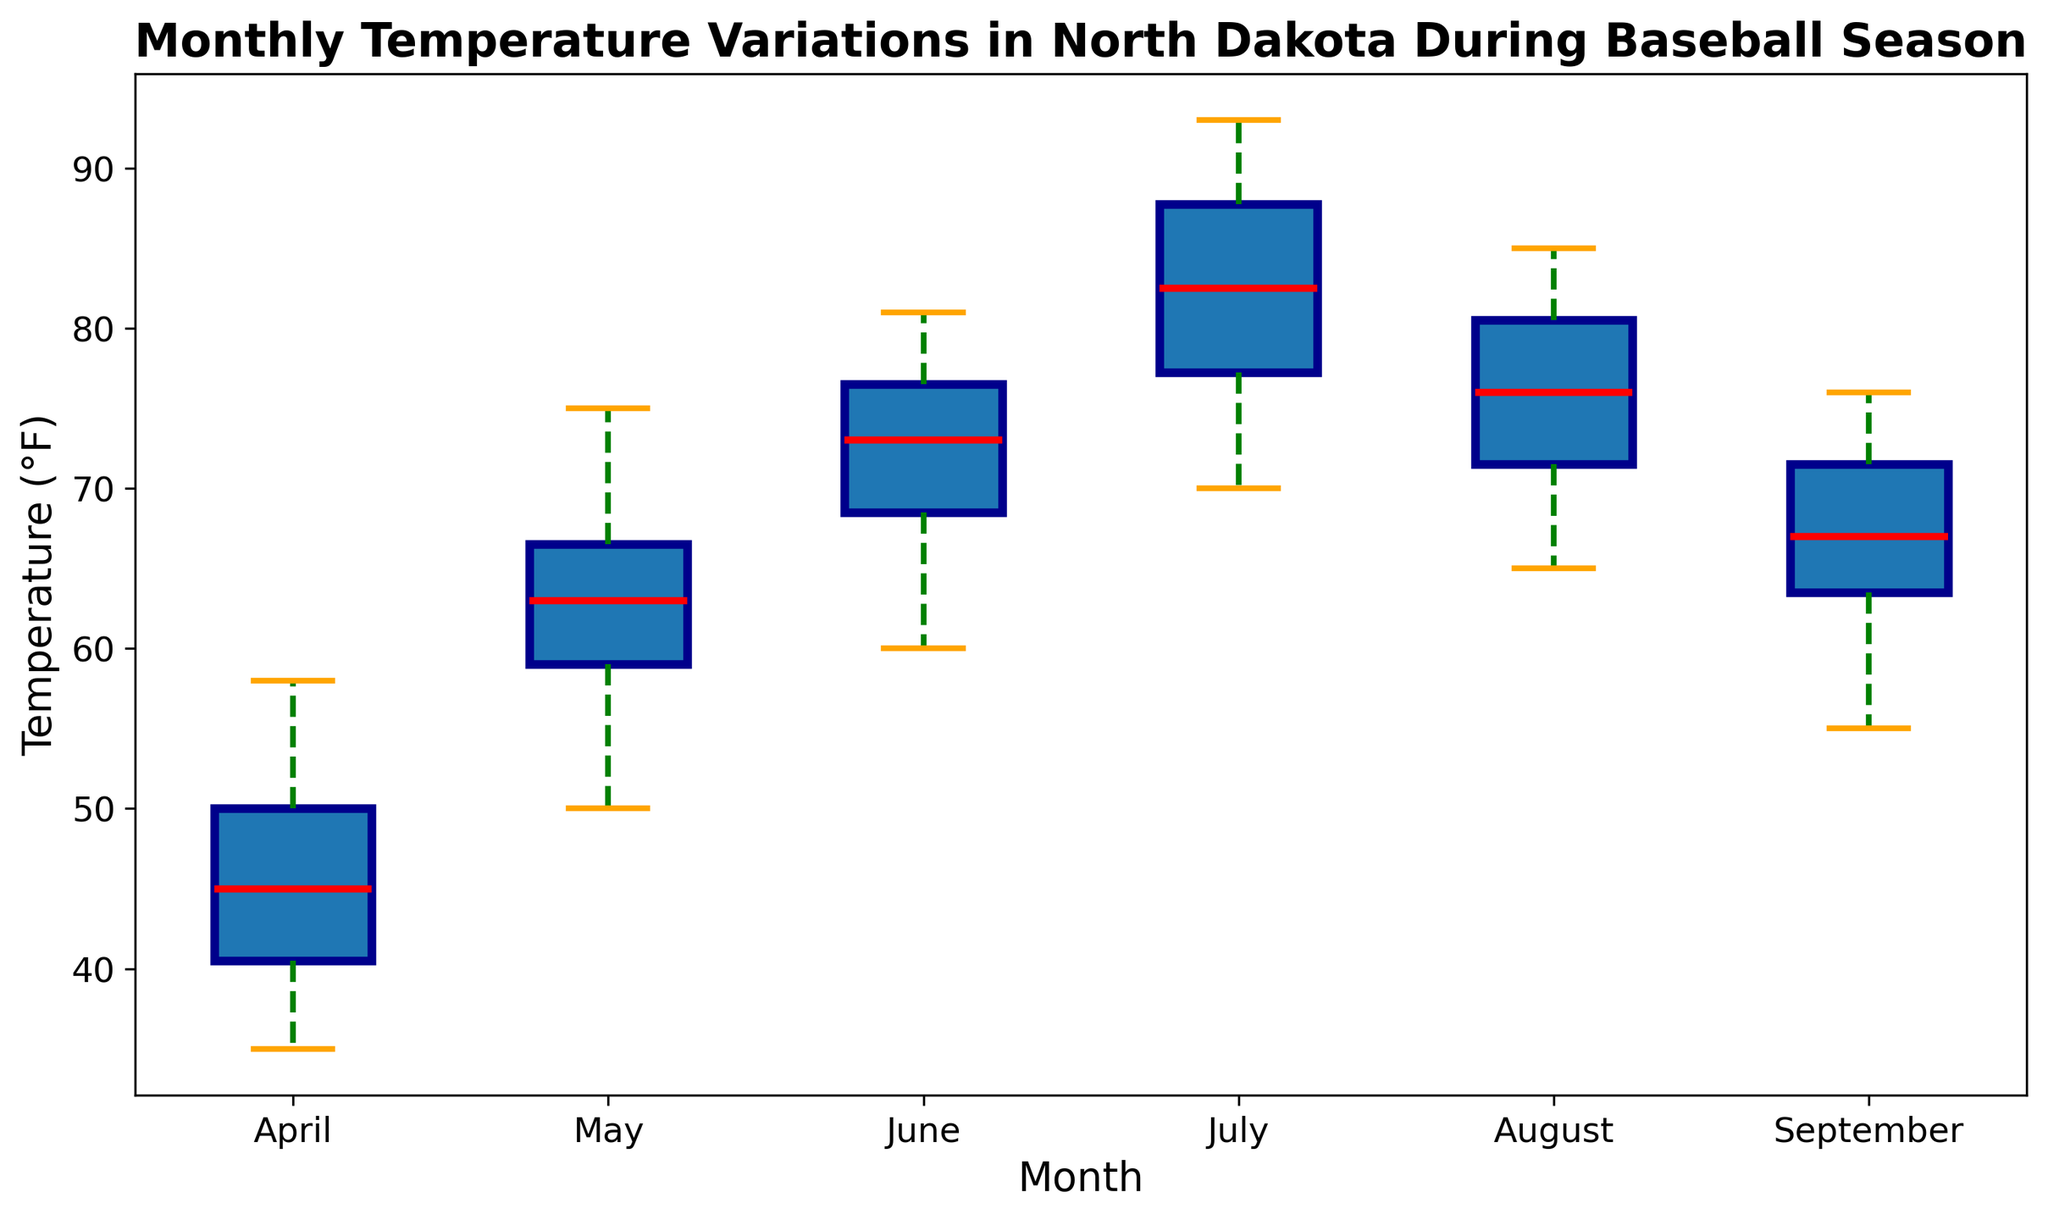What is the median temperature in July? The red line within the box plot for July represents the median temperature. By examining the red line in the July box, we can determine the median temperature is around 83°F.
Answer: 83°F Which month has the highest median temperature? To determine the month with the highest median temperature, we compare the red lines representing the median temperatures across all months. July visibly has the highest median temperature among the months shown.
Answer: July How does the range of temperatures in April compare to that in August? To compare ranges, we look at the lengths of the whiskers and the boxes. April has a lower whisker starting around 35°F and an upper whisker ending around 58°F, indicating a broad temperature range. August ranges roughly from 65°F to 85°F. Although they both have substantial ranges, April has a slightly broader spread (~23°F) compared to August (~22°F) based on whisker lengths.
Answer: April has a broader temperature range In which month is the interquartile range (IQR) the smallest? The IQR is represented by the height of the box. Comparing all the boxes, September's box appears to be the smallest in height, indicating the smallest IQR (i.e., the middle 50% of the data is closer together).
Answer: September Are there any months with outliers, and if so, which ones? Outliers are represented by the small circles outside the whiskers. April and May have visible outliers above and below the whiskers.
Answer: April and May By how much does the median temperature increase from April to May? The median temperature for April is roughly 46°F, and for May, it is about 64°F. The increase is the difference between these medians: 64°F - 46°F.
Answer: 18°F Which month exhibits the greatest temperature variability? Temperature variability can be inferred from the length of the whiskers, as well as the presence of outliers. April shows the greatest variability with the longest whiskers and several outliers compared to other months.
Answer: April What is the temperature range between the 25th and 75th percentiles in June? To find the temperature range between these percentiles (IQR) for June, we look at the top and bottom of the box. The approximate temperatures are 70°F (at the 25th percentile) and 76°F (at the 75th percentile), so the range is 76°F - 70°F.
Answer: 6°F Which month has the smallest temperature range? By comparing the length of the whiskers (range), we find that September has the smallest range, with whiskers spanning from roughly 55°F to 76°F, compared to wider spans in other months.
Answer: September 